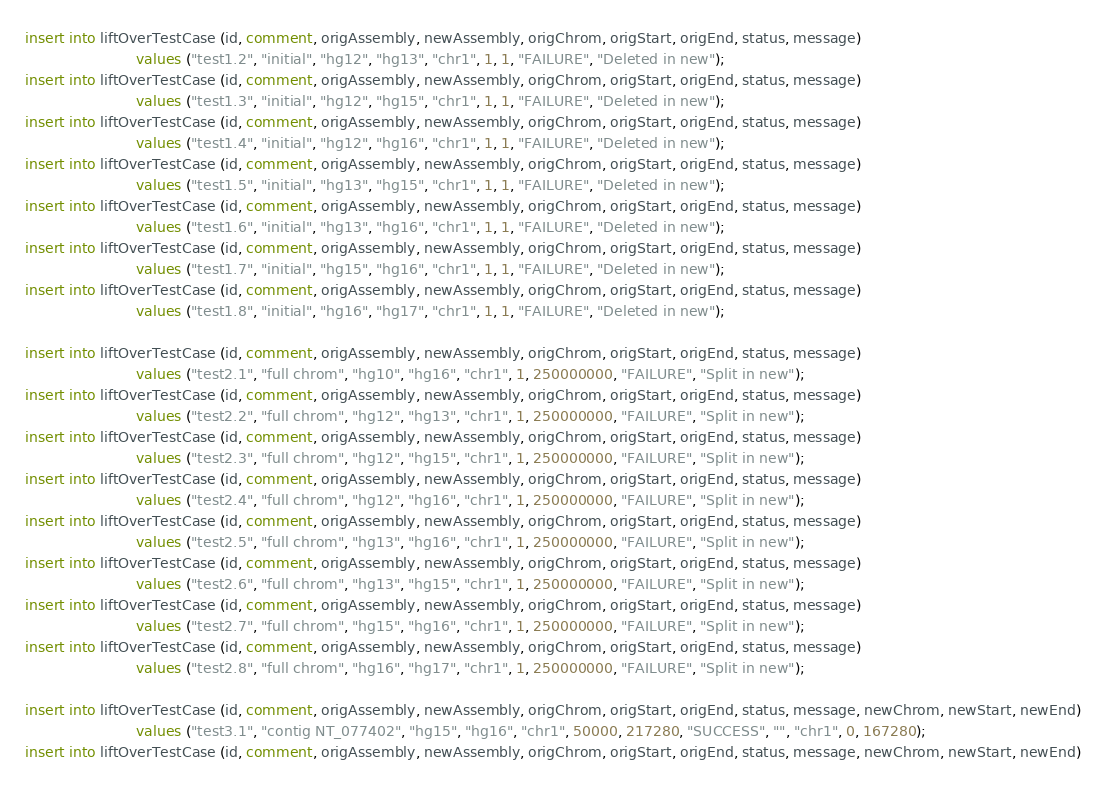<code> <loc_0><loc_0><loc_500><loc_500><_SQL_>insert into liftOverTestCase (id, comment, origAssembly, newAssembly, origChrom, origStart, origEnd, status, message) 
                         values ("test1.2", "initial", "hg12", "hg13", "chr1", 1, 1, "FAILURE", "Deleted in new");
insert into liftOverTestCase (id, comment, origAssembly, newAssembly, origChrom, origStart, origEnd, status, message) 
                         values ("test1.3", "initial", "hg12", "hg15", "chr1", 1, 1, "FAILURE", "Deleted in new");
insert into liftOverTestCase (id, comment, origAssembly, newAssembly, origChrom, origStart, origEnd, status, message) 
                         values ("test1.4", "initial", "hg12", "hg16", "chr1", 1, 1, "FAILURE", "Deleted in new");
insert into liftOverTestCase (id, comment, origAssembly, newAssembly, origChrom, origStart, origEnd, status, message) 
                         values ("test1.5", "initial", "hg13", "hg15", "chr1", 1, 1, "FAILURE", "Deleted in new");
insert into liftOverTestCase (id, comment, origAssembly, newAssembly, origChrom, origStart, origEnd, status, message) 
                         values ("test1.6", "initial", "hg13", "hg16", "chr1", 1, 1, "FAILURE", "Deleted in new");
insert into liftOverTestCase (id, comment, origAssembly, newAssembly, origChrom, origStart, origEnd, status, message) 
                         values ("test1.7", "initial", "hg15", "hg16", "chr1", 1, 1, "FAILURE", "Deleted in new");
insert into liftOverTestCase (id, comment, origAssembly, newAssembly, origChrom, origStart, origEnd, status, message) 
                         values ("test1.8", "initial", "hg16", "hg17", "chr1", 1, 1, "FAILURE", "Deleted in new");

insert into liftOverTestCase (id, comment, origAssembly, newAssembly, origChrom, origStart, origEnd, status, message) 
                         values ("test2.1", "full chrom", "hg10", "hg16", "chr1", 1, 250000000, "FAILURE", "Split in new");
insert into liftOverTestCase (id, comment, origAssembly, newAssembly, origChrom, origStart, origEnd, status, message) 
                         values ("test2.2", "full chrom", "hg12", "hg13", "chr1", 1, 250000000, "FAILURE", "Split in new");
insert into liftOverTestCase (id, comment, origAssembly, newAssembly, origChrom, origStart, origEnd, status, message) 
                         values ("test2.3", "full chrom", "hg12", "hg15", "chr1", 1, 250000000, "FAILURE", "Split in new");
insert into liftOverTestCase (id, comment, origAssembly, newAssembly, origChrom, origStart, origEnd, status, message) 
                         values ("test2.4", "full chrom", "hg12", "hg16", "chr1", 1, 250000000, "FAILURE", "Split in new");
insert into liftOverTestCase (id, comment, origAssembly, newAssembly, origChrom, origStart, origEnd, status, message) 
                         values ("test2.5", "full chrom", "hg13", "hg16", "chr1", 1, 250000000, "FAILURE", "Split in new");
insert into liftOverTestCase (id, comment, origAssembly, newAssembly, origChrom, origStart, origEnd, status, message) 
                         values ("test2.6", "full chrom", "hg13", "hg15", "chr1", 1, 250000000, "FAILURE", "Split in new");
insert into liftOverTestCase (id, comment, origAssembly, newAssembly, origChrom, origStart, origEnd, status, message) 
                         values ("test2.7", "full chrom", "hg15", "hg16", "chr1", 1, 250000000, "FAILURE", "Split in new");
insert into liftOverTestCase (id, comment, origAssembly, newAssembly, origChrom, origStart, origEnd, status, message) 
                         values ("test2.8", "full chrom", "hg16", "hg17", "chr1", 1, 250000000, "FAILURE", "Split in new");

insert into liftOverTestCase (id, comment, origAssembly, newAssembly, origChrom, origStart, origEnd, status, message, newChrom, newStart, newEnd) 
                         values ("test3.1", "contig NT_077402", "hg15", "hg16", "chr1", 50000, 217280, "SUCCESS", "", "chr1", 0, 167280);
insert into liftOverTestCase (id, comment, origAssembly, newAssembly, origChrom, origStart, origEnd, status, message, newChrom, newStart, newEnd) </code> 